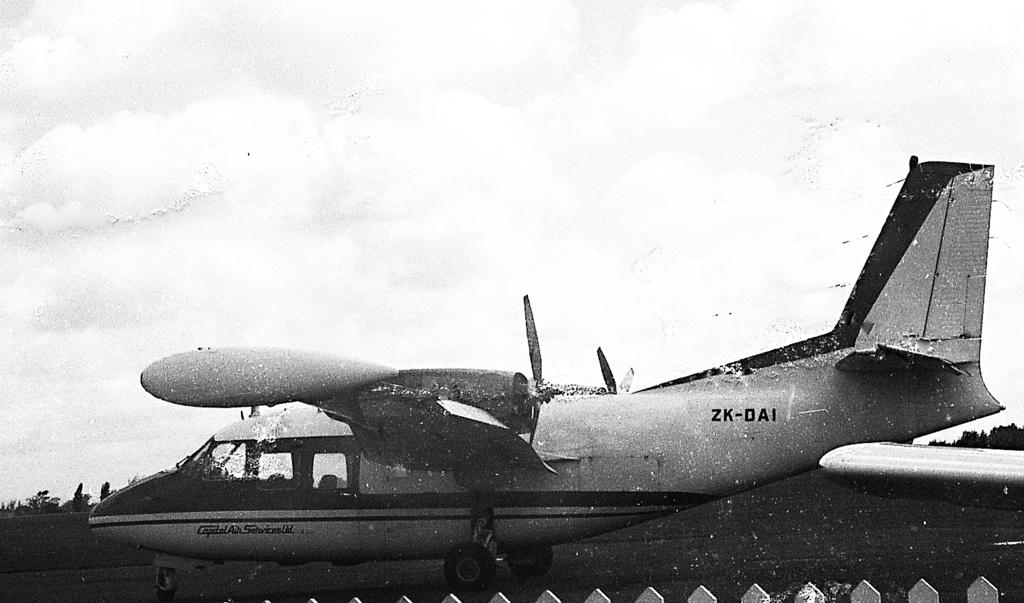Provide a one-sentence caption for the provided image. An airplane with ZK DAI on the rear of the plane. 